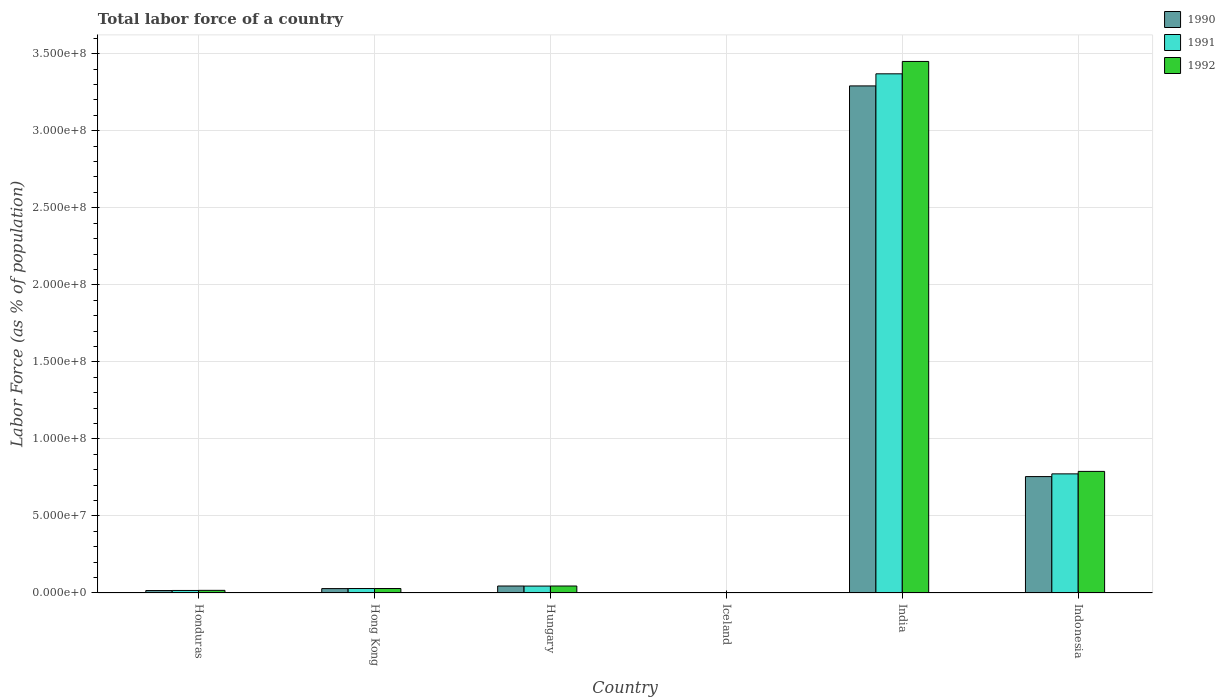How many different coloured bars are there?
Offer a very short reply. 3. How many groups of bars are there?
Ensure brevity in your answer.  6. Are the number of bars on each tick of the X-axis equal?
Make the answer very short. Yes. What is the label of the 3rd group of bars from the left?
Give a very brief answer. Hungary. In how many cases, is the number of bars for a given country not equal to the number of legend labels?
Your response must be concise. 0. What is the percentage of labor force in 1991 in Iceland?
Provide a short and direct response. 1.45e+05. Across all countries, what is the maximum percentage of labor force in 1992?
Provide a short and direct response. 3.45e+08. Across all countries, what is the minimum percentage of labor force in 1990?
Your response must be concise. 1.43e+05. In which country was the percentage of labor force in 1991 maximum?
Ensure brevity in your answer.  India. What is the total percentage of labor force in 1992 in the graph?
Keep it short and to the point. 4.33e+08. What is the difference between the percentage of labor force in 1992 in Honduras and that in India?
Keep it short and to the point. -3.43e+08. What is the difference between the percentage of labor force in 1992 in Hungary and the percentage of labor force in 1990 in India?
Make the answer very short. -3.25e+08. What is the average percentage of labor force in 1992 per country?
Give a very brief answer. 7.22e+07. What is the difference between the percentage of labor force of/in 1990 and percentage of labor force of/in 1992 in Hong Kong?
Offer a terse response. -4.65e+04. What is the ratio of the percentage of labor force in 1992 in Iceland to that in India?
Your response must be concise. 0. What is the difference between the highest and the second highest percentage of labor force in 1991?
Ensure brevity in your answer.  -7.28e+07. What is the difference between the highest and the lowest percentage of labor force in 1990?
Keep it short and to the point. 3.29e+08. In how many countries, is the percentage of labor force in 1992 greater than the average percentage of labor force in 1992 taken over all countries?
Provide a short and direct response. 2. Is the sum of the percentage of labor force in 1991 in Hong Kong and Indonesia greater than the maximum percentage of labor force in 1990 across all countries?
Ensure brevity in your answer.  No. What does the 1st bar from the right in Iceland represents?
Your response must be concise. 1992. Are the values on the major ticks of Y-axis written in scientific E-notation?
Offer a terse response. Yes. Does the graph contain any zero values?
Provide a succinct answer. No. Does the graph contain grids?
Ensure brevity in your answer.  Yes. How many legend labels are there?
Your answer should be very brief. 3. What is the title of the graph?
Keep it short and to the point. Total labor force of a country. What is the label or title of the Y-axis?
Provide a succinct answer. Labor Force (as % of population). What is the Labor Force (as % of population) of 1990 in Honduras?
Your response must be concise. 1.59e+06. What is the Labor Force (as % of population) of 1991 in Honduras?
Offer a very short reply. 1.64e+06. What is the Labor Force (as % of population) of 1992 in Honduras?
Provide a short and direct response. 1.71e+06. What is the Labor Force (as % of population) in 1990 in Hong Kong?
Provide a succinct answer. 2.85e+06. What is the Labor Force (as % of population) of 1991 in Hong Kong?
Your response must be concise. 2.90e+06. What is the Labor Force (as % of population) in 1992 in Hong Kong?
Ensure brevity in your answer.  2.89e+06. What is the Labor Force (as % of population) of 1990 in Hungary?
Offer a very short reply. 4.53e+06. What is the Labor Force (as % of population) of 1991 in Hungary?
Make the answer very short. 4.49e+06. What is the Labor Force (as % of population) in 1992 in Hungary?
Offer a terse response. 4.53e+06. What is the Labor Force (as % of population) in 1990 in Iceland?
Provide a short and direct response. 1.43e+05. What is the Labor Force (as % of population) of 1991 in Iceland?
Offer a terse response. 1.45e+05. What is the Labor Force (as % of population) of 1992 in Iceland?
Your answer should be compact. 1.49e+05. What is the Labor Force (as % of population) of 1990 in India?
Ensure brevity in your answer.  3.29e+08. What is the Labor Force (as % of population) of 1991 in India?
Make the answer very short. 3.37e+08. What is the Labor Force (as % of population) of 1992 in India?
Your answer should be very brief. 3.45e+08. What is the Labor Force (as % of population) in 1990 in Indonesia?
Your response must be concise. 7.55e+07. What is the Labor Force (as % of population) of 1991 in Indonesia?
Provide a succinct answer. 7.73e+07. What is the Labor Force (as % of population) of 1992 in Indonesia?
Offer a terse response. 7.89e+07. Across all countries, what is the maximum Labor Force (as % of population) of 1990?
Your response must be concise. 3.29e+08. Across all countries, what is the maximum Labor Force (as % of population) of 1991?
Give a very brief answer. 3.37e+08. Across all countries, what is the maximum Labor Force (as % of population) in 1992?
Your answer should be very brief. 3.45e+08. Across all countries, what is the minimum Labor Force (as % of population) of 1990?
Make the answer very short. 1.43e+05. Across all countries, what is the minimum Labor Force (as % of population) in 1991?
Keep it short and to the point. 1.45e+05. Across all countries, what is the minimum Labor Force (as % of population) of 1992?
Make the answer very short. 1.49e+05. What is the total Labor Force (as % of population) of 1990 in the graph?
Offer a very short reply. 4.14e+08. What is the total Labor Force (as % of population) of 1991 in the graph?
Offer a very short reply. 4.23e+08. What is the total Labor Force (as % of population) in 1992 in the graph?
Ensure brevity in your answer.  4.33e+08. What is the difference between the Labor Force (as % of population) of 1990 in Honduras and that in Hong Kong?
Offer a terse response. -1.26e+06. What is the difference between the Labor Force (as % of population) of 1991 in Honduras and that in Hong Kong?
Your response must be concise. -1.26e+06. What is the difference between the Labor Force (as % of population) in 1992 in Honduras and that in Hong Kong?
Offer a very short reply. -1.18e+06. What is the difference between the Labor Force (as % of population) in 1990 in Honduras and that in Hungary?
Keep it short and to the point. -2.93e+06. What is the difference between the Labor Force (as % of population) of 1991 in Honduras and that in Hungary?
Ensure brevity in your answer.  -2.85e+06. What is the difference between the Labor Force (as % of population) of 1992 in Honduras and that in Hungary?
Your answer should be very brief. -2.82e+06. What is the difference between the Labor Force (as % of population) of 1990 in Honduras and that in Iceland?
Your answer should be compact. 1.45e+06. What is the difference between the Labor Force (as % of population) in 1991 in Honduras and that in Iceland?
Ensure brevity in your answer.  1.50e+06. What is the difference between the Labor Force (as % of population) in 1992 in Honduras and that in Iceland?
Your response must be concise. 1.56e+06. What is the difference between the Labor Force (as % of population) of 1990 in Honduras and that in India?
Provide a short and direct response. -3.28e+08. What is the difference between the Labor Force (as % of population) in 1991 in Honduras and that in India?
Keep it short and to the point. -3.35e+08. What is the difference between the Labor Force (as % of population) in 1992 in Honduras and that in India?
Offer a very short reply. -3.43e+08. What is the difference between the Labor Force (as % of population) of 1990 in Honduras and that in Indonesia?
Provide a succinct answer. -7.40e+07. What is the difference between the Labor Force (as % of population) in 1991 in Honduras and that in Indonesia?
Offer a very short reply. -7.57e+07. What is the difference between the Labor Force (as % of population) in 1992 in Honduras and that in Indonesia?
Provide a short and direct response. -7.72e+07. What is the difference between the Labor Force (as % of population) in 1990 in Hong Kong and that in Hungary?
Your response must be concise. -1.68e+06. What is the difference between the Labor Force (as % of population) of 1991 in Hong Kong and that in Hungary?
Ensure brevity in your answer.  -1.59e+06. What is the difference between the Labor Force (as % of population) in 1992 in Hong Kong and that in Hungary?
Make the answer very short. -1.64e+06. What is the difference between the Labor Force (as % of population) of 1990 in Hong Kong and that in Iceland?
Keep it short and to the point. 2.71e+06. What is the difference between the Labor Force (as % of population) in 1991 in Hong Kong and that in Iceland?
Give a very brief answer. 2.76e+06. What is the difference between the Labor Force (as % of population) of 1992 in Hong Kong and that in Iceland?
Your answer should be compact. 2.75e+06. What is the difference between the Labor Force (as % of population) of 1990 in Hong Kong and that in India?
Offer a terse response. -3.26e+08. What is the difference between the Labor Force (as % of population) of 1991 in Hong Kong and that in India?
Make the answer very short. -3.34e+08. What is the difference between the Labor Force (as % of population) in 1992 in Hong Kong and that in India?
Offer a terse response. -3.42e+08. What is the difference between the Labor Force (as % of population) of 1990 in Hong Kong and that in Indonesia?
Make the answer very short. -7.27e+07. What is the difference between the Labor Force (as % of population) in 1991 in Hong Kong and that in Indonesia?
Your answer should be compact. -7.44e+07. What is the difference between the Labor Force (as % of population) of 1992 in Hong Kong and that in Indonesia?
Keep it short and to the point. -7.60e+07. What is the difference between the Labor Force (as % of population) of 1990 in Hungary and that in Iceland?
Offer a very short reply. 4.38e+06. What is the difference between the Labor Force (as % of population) in 1991 in Hungary and that in Iceland?
Keep it short and to the point. 4.34e+06. What is the difference between the Labor Force (as % of population) of 1992 in Hungary and that in Iceland?
Your answer should be very brief. 4.38e+06. What is the difference between the Labor Force (as % of population) of 1990 in Hungary and that in India?
Keep it short and to the point. -3.25e+08. What is the difference between the Labor Force (as % of population) of 1991 in Hungary and that in India?
Ensure brevity in your answer.  -3.32e+08. What is the difference between the Labor Force (as % of population) in 1992 in Hungary and that in India?
Ensure brevity in your answer.  -3.40e+08. What is the difference between the Labor Force (as % of population) of 1990 in Hungary and that in Indonesia?
Provide a short and direct response. -7.10e+07. What is the difference between the Labor Force (as % of population) of 1991 in Hungary and that in Indonesia?
Offer a terse response. -7.28e+07. What is the difference between the Labor Force (as % of population) of 1992 in Hungary and that in Indonesia?
Provide a succinct answer. -7.44e+07. What is the difference between the Labor Force (as % of population) in 1990 in Iceland and that in India?
Give a very brief answer. -3.29e+08. What is the difference between the Labor Force (as % of population) in 1991 in Iceland and that in India?
Keep it short and to the point. -3.37e+08. What is the difference between the Labor Force (as % of population) in 1992 in Iceland and that in India?
Provide a short and direct response. -3.45e+08. What is the difference between the Labor Force (as % of population) in 1990 in Iceland and that in Indonesia?
Give a very brief answer. -7.54e+07. What is the difference between the Labor Force (as % of population) of 1991 in Iceland and that in Indonesia?
Your response must be concise. -7.72e+07. What is the difference between the Labor Force (as % of population) of 1992 in Iceland and that in Indonesia?
Ensure brevity in your answer.  -7.88e+07. What is the difference between the Labor Force (as % of population) of 1990 in India and that in Indonesia?
Keep it short and to the point. 2.54e+08. What is the difference between the Labor Force (as % of population) in 1991 in India and that in Indonesia?
Give a very brief answer. 2.60e+08. What is the difference between the Labor Force (as % of population) in 1992 in India and that in Indonesia?
Offer a terse response. 2.66e+08. What is the difference between the Labor Force (as % of population) in 1990 in Honduras and the Labor Force (as % of population) in 1991 in Hong Kong?
Your answer should be compact. -1.31e+06. What is the difference between the Labor Force (as % of population) in 1990 in Honduras and the Labor Force (as % of population) in 1992 in Hong Kong?
Offer a terse response. -1.30e+06. What is the difference between the Labor Force (as % of population) in 1991 in Honduras and the Labor Force (as % of population) in 1992 in Hong Kong?
Keep it short and to the point. -1.25e+06. What is the difference between the Labor Force (as % of population) in 1990 in Honduras and the Labor Force (as % of population) in 1991 in Hungary?
Make the answer very short. -2.90e+06. What is the difference between the Labor Force (as % of population) of 1990 in Honduras and the Labor Force (as % of population) of 1992 in Hungary?
Provide a short and direct response. -2.94e+06. What is the difference between the Labor Force (as % of population) in 1991 in Honduras and the Labor Force (as % of population) in 1992 in Hungary?
Offer a very short reply. -2.89e+06. What is the difference between the Labor Force (as % of population) in 1990 in Honduras and the Labor Force (as % of population) in 1991 in Iceland?
Ensure brevity in your answer.  1.45e+06. What is the difference between the Labor Force (as % of population) of 1990 in Honduras and the Labor Force (as % of population) of 1992 in Iceland?
Offer a very short reply. 1.44e+06. What is the difference between the Labor Force (as % of population) in 1991 in Honduras and the Labor Force (as % of population) in 1992 in Iceland?
Your answer should be compact. 1.49e+06. What is the difference between the Labor Force (as % of population) of 1990 in Honduras and the Labor Force (as % of population) of 1991 in India?
Keep it short and to the point. -3.35e+08. What is the difference between the Labor Force (as % of population) in 1990 in Honduras and the Labor Force (as % of population) in 1992 in India?
Offer a terse response. -3.43e+08. What is the difference between the Labor Force (as % of population) of 1991 in Honduras and the Labor Force (as % of population) of 1992 in India?
Your answer should be compact. -3.43e+08. What is the difference between the Labor Force (as % of population) of 1990 in Honduras and the Labor Force (as % of population) of 1991 in Indonesia?
Your answer should be very brief. -7.57e+07. What is the difference between the Labor Force (as % of population) in 1990 in Honduras and the Labor Force (as % of population) in 1992 in Indonesia?
Your answer should be very brief. -7.73e+07. What is the difference between the Labor Force (as % of population) in 1991 in Honduras and the Labor Force (as % of population) in 1992 in Indonesia?
Keep it short and to the point. -7.73e+07. What is the difference between the Labor Force (as % of population) of 1990 in Hong Kong and the Labor Force (as % of population) of 1991 in Hungary?
Your answer should be very brief. -1.64e+06. What is the difference between the Labor Force (as % of population) in 1990 in Hong Kong and the Labor Force (as % of population) in 1992 in Hungary?
Offer a terse response. -1.68e+06. What is the difference between the Labor Force (as % of population) of 1991 in Hong Kong and the Labor Force (as % of population) of 1992 in Hungary?
Ensure brevity in your answer.  -1.63e+06. What is the difference between the Labor Force (as % of population) of 1990 in Hong Kong and the Labor Force (as % of population) of 1991 in Iceland?
Provide a succinct answer. 2.70e+06. What is the difference between the Labor Force (as % of population) of 1990 in Hong Kong and the Labor Force (as % of population) of 1992 in Iceland?
Provide a succinct answer. 2.70e+06. What is the difference between the Labor Force (as % of population) in 1991 in Hong Kong and the Labor Force (as % of population) in 1992 in Iceland?
Provide a succinct answer. 2.75e+06. What is the difference between the Labor Force (as % of population) in 1990 in Hong Kong and the Labor Force (as % of population) in 1991 in India?
Ensure brevity in your answer.  -3.34e+08. What is the difference between the Labor Force (as % of population) in 1990 in Hong Kong and the Labor Force (as % of population) in 1992 in India?
Provide a short and direct response. -3.42e+08. What is the difference between the Labor Force (as % of population) in 1991 in Hong Kong and the Labor Force (as % of population) in 1992 in India?
Keep it short and to the point. -3.42e+08. What is the difference between the Labor Force (as % of population) in 1990 in Hong Kong and the Labor Force (as % of population) in 1991 in Indonesia?
Your answer should be very brief. -7.45e+07. What is the difference between the Labor Force (as % of population) in 1990 in Hong Kong and the Labor Force (as % of population) in 1992 in Indonesia?
Provide a succinct answer. -7.61e+07. What is the difference between the Labor Force (as % of population) of 1991 in Hong Kong and the Labor Force (as % of population) of 1992 in Indonesia?
Your answer should be compact. -7.60e+07. What is the difference between the Labor Force (as % of population) in 1990 in Hungary and the Labor Force (as % of population) in 1991 in Iceland?
Your response must be concise. 4.38e+06. What is the difference between the Labor Force (as % of population) of 1990 in Hungary and the Labor Force (as % of population) of 1992 in Iceland?
Make the answer very short. 4.38e+06. What is the difference between the Labor Force (as % of population) of 1991 in Hungary and the Labor Force (as % of population) of 1992 in Iceland?
Give a very brief answer. 4.34e+06. What is the difference between the Labor Force (as % of population) in 1990 in Hungary and the Labor Force (as % of population) in 1991 in India?
Provide a succinct answer. -3.32e+08. What is the difference between the Labor Force (as % of population) of 1990 in Hungary and the Labor Force (as % of population) of 1992 in India?
Offer a terse response. -3.40e+08. What is the difference between the Labor Force (as % of population) of 1991 in Hungary and the Labor Force (as % of population) of 1992 in India?
Provide a succinct answer. -3.40e+08. What is the difference between the Labor Force (as % of population) in 1990 in Hungary and the Labor Force (as % of population) in 1991 in Indonesia?
Make the answer very short. -7.28e+07. What is the difference between the Labor Force (as % of population) of 1990 in Hungary and the Labor Force (as % of population) of 1992 in Indonesia?
Offer a very short reply. -7.44e+07. What is the difference between the Labor Force (as % of population) of 1991 in Hungary and the Labor Force (as % of population) of 1992 in Indonesia?
Offer a terse response. -7.44e+07. What is the difference between the Labor Force (as % of population) in 1990 in Iceland and the Labor Force (as % of population) in 1991 in India?
Give a very brief answer. -3.37e+08. What is the difference between the Labor Force (as % of population) in 1990 in Iceland and the Labor Force (as % of population) in 1992 in India?
Your answer should be compact. -3.45e+08. What is the difference between the Labor Force (as % of population) in 1991 in Iceland and the Labor Force (as % of population) in 1992 in India?
Offer a terse response. -3.45e+08. What is the difference between the Labor Force (as % of population) of 1990 in Iceland and the Labor Force (as % of population) of 1991 in Indonesia?
Your answer should be compact. -7.72e+07. What is the difference between the Labor Force (as % of population) in 1990 in Iceland and the Labor Force (as % of population) in 1992 in Indonesia?
Provide a succinct answer. -7.88e+07. What is the difference between the Labor Force (as % of population) of 1991 in Iceland and the Labor Force (as % of population) of 1992 in Indonesia?
Make the answer very short. -7.88e+07. What is the difference between the Labor Force (as % of population) in 1990 in India and the Labor Force (as % of population) in 1991 in Indonesia?
Offer a very short reply. 2.52e+08. What is the difference between the Labor Force (as % of population) in 1990 in India and the Labor Force (as % of population) in 1992 in Indonesia?
Make the answer very short. 2.50e+08. What is the difference between the Labor Force (as % of population) of 1991 in India and the Labor Force (as % of population) of 1992 in Indonesia?
Offer a terse response. 2.58e+08. What is the average Labor Force (as % of population) in 1990 per country?
Your answer should be very brief. 6.90e+07. What is the average Labor Force (as % of population) of 1991 per country?
Make the answer very short. 7.06e+07. What is the average Labor Force (as % of population) in 1992 per country?
Offer a very short reply. 7.22e+07. What is the difference between the Labor Force (as % of population) of 1990 and Labor Force (as % of population) of 1991 in Honduras?
Provide a succinct answer. -5.05e+04. What is the difference between the Labor Force (as % of population) of 1990 and Labor Force (as % of population) of 1992 in Honduras?
Your answer should be compact. -1.22e+05. What is the difference between the Labor Force (as % of population) in 1991 and Labor Force (as % of population) in 1992 in Honduras?
Give a very brief answer. -7.12e+04. What is the difference between the Labor Force (as % of population) in 1990 and Labor Force (as % of population) in 1991 in Hong Kong?
Your response must be concise. -5.33e+04. What is the difference between the Labor Force (as % of population) in 1990 and Labor Force (as % of population) in 1992 in Hong Kong?
Provide a succinct answer. -4.65e+04. What is the difference between the Labor Force (as % of population) in 1991 and Labor Force (as % of population) in 1992 in Hong Kong?
Offer a terse response. 6796. What is the difference between the Labor Force (as % of population) of 1990 and Labor Force (as % of population) of 1991 in Hungary?
Your answer should be compact. 3.71e+04. What is the difference between the Labor Force (as % of population) of 1990 and Labor Force (as % of population) of 1992 in Hungary?
Give a very brief answer. -5744. What is the difference between the Labor Force (as % of population) in 1991 and Labor Force (as % of population) in 1992 in Hungary?
Give a very brief answer. -4.28e+04. What is the difference between the Labor Force (as % of population) of 1990 and Labor Force (as % of population) of 1991 in Iceland?
Your answer should be compact. -2346. What is the difference between the Labor Force (as % of population) of 1990 and Labor Force (as % of population) of 1992 in Iceland?
Give a very brief answer. -5928. What is the difference between the Labor Force (as % of population) in 1991 and Labor Force (as % of population) in 1992 in Iceland?
Your response must be concise. -3582. What is the difference between the Labor Force (as % of population) of 1990 and Labor Force (as % of population) of 1991 in India?
Offer a very short reply. -7.85e+06. What is the difference between the Labor Force (as % of population) in 1990 and Labor Force (as % of population) in 1992 in India?
Offer a terse response. -1.59e+07. What is the difference between the Labor Force (as % of population) in 1991 and Labor Force (as % of population) in 1992 in India?
Make the answer very short. -8.02e+06. What is the difference between the Labor Force (as % of population) in 1990 and Labor Force (as % of population) in 1991 in Indonesia?
Your response must be concise. -1.77e+06. What is the difference between the Labor Force (as % of population) in 1990 and Labor Force (as % of population) in 1992 in Indonesia?
Offer a terse response. -3.37e+06. What is the difference between the Labor Force (as % of population) in 1991 and Labor Force (as % of population) in 1992 in Indonesia?
Ensure brevity in your answer.  -1.61e+06. What is the ratio of the Labor Force (as % of population) of 1990 in Honduras to that in Hong Kong?
Ensure brevity in your answer.  0.56. What is the ratio of the Labor Force (as % of population) of 1991 in Honduras to that in Hong Kong?
Offer a terse response. 0.57. What is the ratio of the Labor Force (as % of population) of 1992 in Honduras to that in Hong Kong?
Your answer should be very brief. 0.59. What is the ratio of the Labor Force (as % of population) in 1990 in Honduras to that in Hungary?
Provide a succinct answer. 0.35. What is the ratio of the Labor Force (as % of population) in 1991 in Honduras to that in Hungary?
Provide a short and direct response. 0.37. What is the ratio of the Labor Force (as % of population) of 1992 in Honduras to that in Hungary?
Provide a succinct answer. 0.38. What is the ratio of the Labor Force (as % of population) in 1990 in Honduras to that in Iceland?
Give a very brief answer. 11.12. What is the ratio of the Labor Force (as % of population) of 1991 in Honduras to that in Iceland?
Keep it short and to the point. 11.29. What is the ratio of the Labor Force (as % of population) in 1992 in Honduras to that in Iceland?
Your answer should be very brief. 11.5. What is the ratio of the Labor Force (as % of population) in 1990 in Honduras to that in India?
Provide a short and direct response. 0. What is the ratio of the Labor Force (as % of population) in 1991 in Honduras to that in India?
Your response must be concise. 0. What is the ratio of the Labor Force (as % of population) of 1992 in Honduras to that in India?
Offer a terse response. 0.01. What is the ratio of the Labor Force (as % of population) of 1990 in Honduras to that in Indonesia?
Provide a short and direct response. 0.02. What is the ratio of the Labor Force (as % of population) in 1991 in Honduras to that in Indonesia?
Offer a very short reply. 0.02. What is the ratio of the Labor Force (as % of population) of 1992 in Honduras to that in Indonesia?
Your answer should be compact. 0.02. What is the ratio of the Labor Force (as % of population) in 1990 in Hong Kong to that in Hungary?
Make the answer very short. 0.63. What is the ratio of the Labor Force (as % of population) in 1991 in Hong Kong to that in Hungary?
Your answer should be compact. 0.65. What is the ratio of the Labor Force (as % of population) of 1992 in Hong Kong to that in Hungary?
Ensure brevity in your answer.  0.64. What is the ratio of the Labor Force (as % of population) in 1990 in Hong Kong to that in Iceland?
Offer a terse response. 19.91. What is the ratio of the Labor Force (as % of population) in 1991 in Hong Kong to that in Iceland?
Keep it short and to the point. 19.96. What is the ratio of the Labor Force (as % of population) in 1992 in Hong Kong to that in Iceland?
Provide a short and direct response. 19.43. What is the ratio of the Labor Force (as % of population) in 1990 in Hong Kong to that in India?
Offer a terse response. 0.01. What is the ratio of the Labor Force (as % of population) of 1991 in Hong Kong to that in India?
Provide a short and direct response. 0.01. What is the ratio of the Labor Force (as % of population) in 1992 in Hong Kong to that in India?
Give a very brief answer. 0.01. What is the ratio of the Labor Force (as % of population) in 1990 in Hong Kong to that in Indonesia?
Your answer should be compact. 0.04. What is the ratio of the Labor Force (as % of population) of 1991 in Hong Kong to that in Indonesia?
Ensure brevity in your answer.  0.04. What is the ratio of the Labor Force (as % of population) in 1992 in Hong Kong to that in Indonesia?
Offer a terse response. 0.04. What is the ratio of the Labor Force (as % of population) of 1990 in Hungary to that in Iceland?
Your response must be concise. 31.64. What is the ratio of the Labor Force (as % of population) of 1991 in Hungary to that in Iceland?
Make the answer very short. 30.87. What is the ratio of the Labor Force (as % of population) of 1992 in Hungary to that in Iceland?
Offer a terse response. 30.42. What is the ratio of the Labor Force (as % of population) of 1990 in Hungary to that in India?
Your answer should be compact. 0.01. What is the ratio of the Labor Force (as % of population) in 1991 in Hungary to that in India?
Your answer should be compact. 0.01. What is the ratio of the Labor Force (as % of population) in 1992 in Hungary to that in India?
Offer a terse response. 0.01. What is the ratio of the Labor Force (as % of population) in 1990 in Hungary to that in Indonesia?
Offer a very short reply. 0.06. What is the ratio of the Labor Force (as % of population) of 1991 in Hungary to that in Indonesia?
Ensure brevity in your answer.  0.06. What is the ratio of the Labor Force (as % of population) in 1992 in Hungary to that in Indonesia?
Keep it short and to the point. 0.06. What is the ratio of the Labor Force (as % of population) of 1990 in Iceland to that in Indonesia?
Ensure brevity in your answer.  0. What is the ratio of the Labor Force (as % of population) in 1991 in Iceland to that in Indonesia?
Offer a very short reply. 0. What is the ratio of the Labor Force (as % of population) of 1992 in Iceland to that in Indonesia?
Your response must be concise. 0. What is the ratio of the Labor Force (as % of population) of 1990 in India to that in Indonesia?
Ensure brevity in your answer.  4.36. What is the ratio of the Labor Force (as % of population) in 1991 in India to that in Indonesia?
Ensure brevity in your answer.  4.36. What is the ratio of the Labor Force (as % of population) of 1992 in India to that in Indonesia?
Your response must be concise. 4.37. What is the difference between the highest and the second highest Labor Force (as % of population) of 1990?
Offer a terse response. 2.54e+08. What is the difference between the highest and the second highest Labor Force (as % of population) in 1991?
Ensure brevity in your answer.  2.60e+08. What is the difference between the highest and the second highest Labor Force (as % of population) of 1992?
Your answer should be compact. 2.66e+08. What is the difference between the highest and the lowest Labor Force (as % of population) in 1990?
Offer a very short reply. 3.29e+08. What is the difference between the highest and the lowest Labor Force (as % of population) of 1991?
Give a very brief answer. 3.37e+08. What is the difference between the highest and the lowest Labor Force (as % of population) in 1992?
Your answer should be very brief. 3.45e+08. 